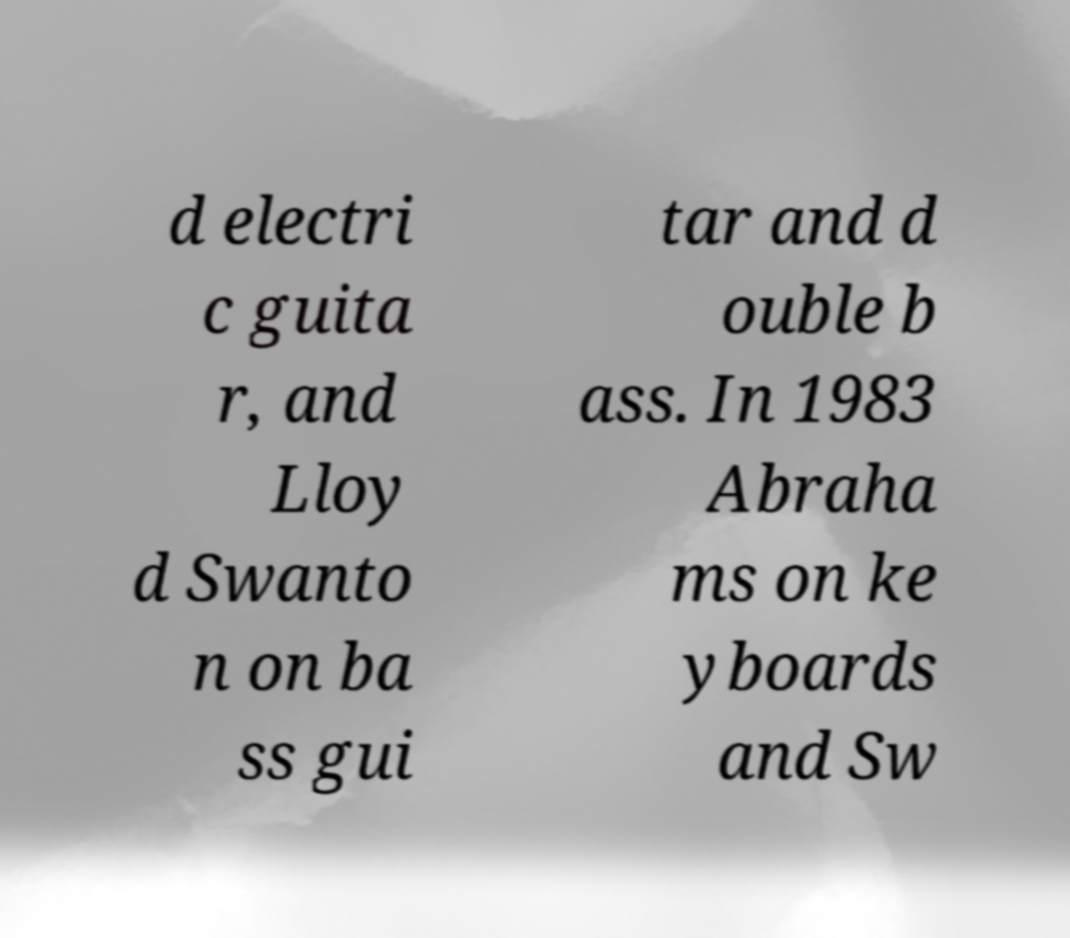What messages or text are displayed in this image? I need them in a readable, typed format. d electri c guita r, and Lloy d Swanto n on ba ss gui tar and d ouble b ass. In 1983 Abraha ms on ke yboards and Sw 